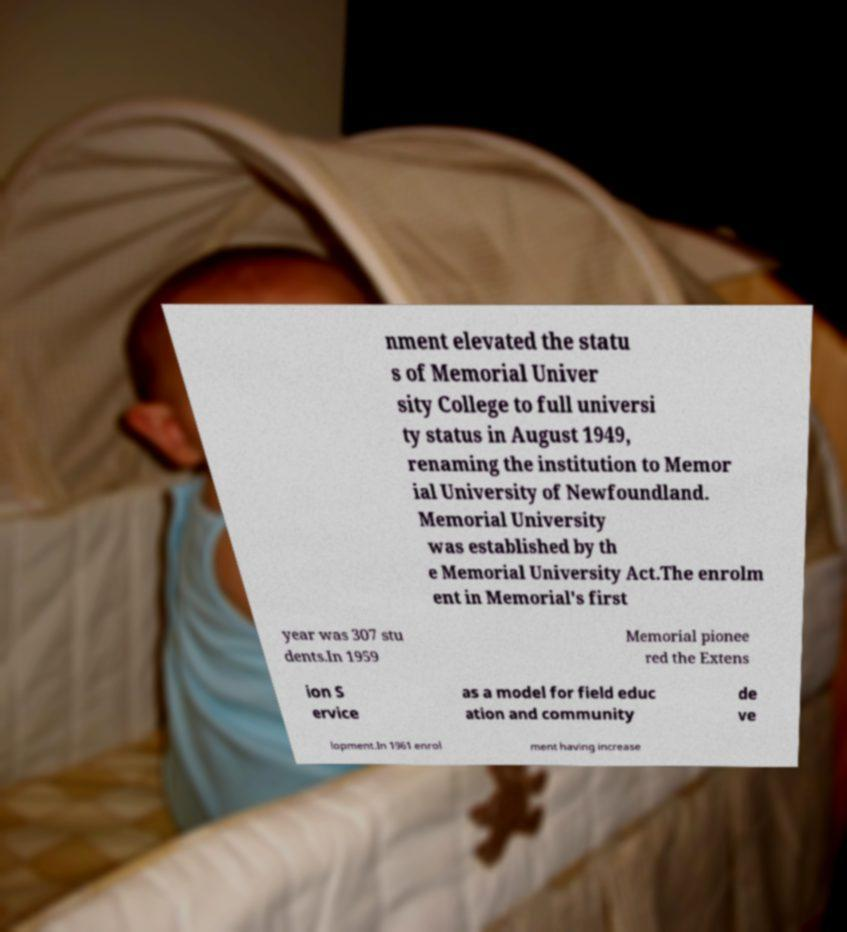For documentation purposes, I need the text within this image transcribed. Could you provide that? nment elevated the statu s of Memorial Univer sity College to full universi ty status in August 1949, renaming the institution to Memor ial University of Newfoundland. Memorial University was established by th e Memorial University Act.The enrolm ent in Memorial's first year was 307 stu dents.In 1959 Memorial pionee red the Extens ion S ervice as a model for field educ ation and community de ve lopment.In 1961 enrol ment having increase 